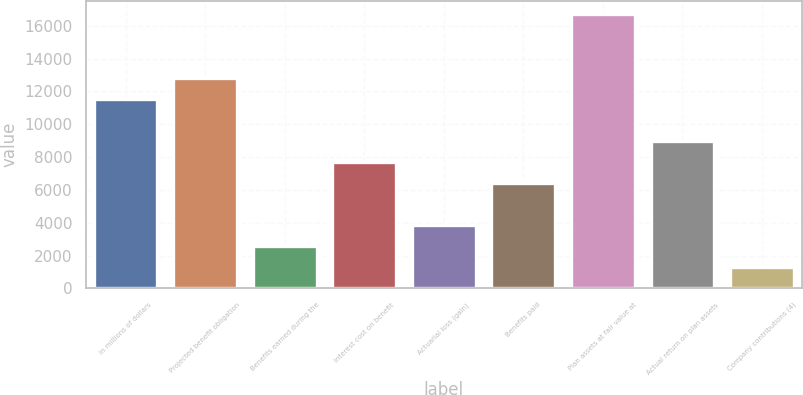Convert chart to OTSL. <chart><loc_0><loc_0><loc_500><loc_500><bar_chart><fcel>In millions of dollars<fcel>Projected benefit obligation<fcel>Benefits earned during the<fcel>Interest cost on benefit<fcel>Actuarial loss (gain)<fcel>Benefits paid<fcel>Plan assets at fair value at<fcel>Actual return on plan assets<fcel>Company contributions (4)<nl><fcel>11556.4<fcel>12840<fcel>2571.2<fcel>7705.6<fcel>3854.8<fcel>6422<fcel>16690.8<fcel>8989.2<fcel>1287.6<nl></chart> 